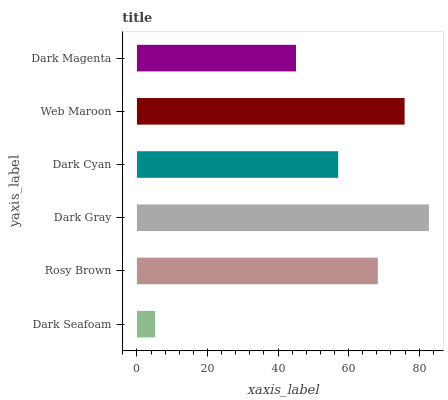Is Dark Seafoam the minimum?
Answer yes or no. Yes. Is Dark Gray the maximum?
Answer yes or no. Yes. Is Rosy Brown the minimum?
Answer yes or no. No. Is Rosy Brown the maximum?
Answer yes or no. No. Is Rosy Brown greater than Dark Seafoam?
Answer yes or no. Yes. Is Dark Seafoam less than Rosy Brown?
Answer yes or no. Yes. Is Dark Seafoam greater than Rosy Brown?
Answer yes or no. No. Is Rosy Brown less than Dark Seafoam?
Answer yes or no. No. Is Rosy Brown the high median?
Answer yes or no. Yes. Is Dark Cyan the low median?
Answer yes or no. Yes. Is Web Maroon the high median?
Answer yes or no. No. Is Dark Gray the low median?
Answer yes or no. No. 